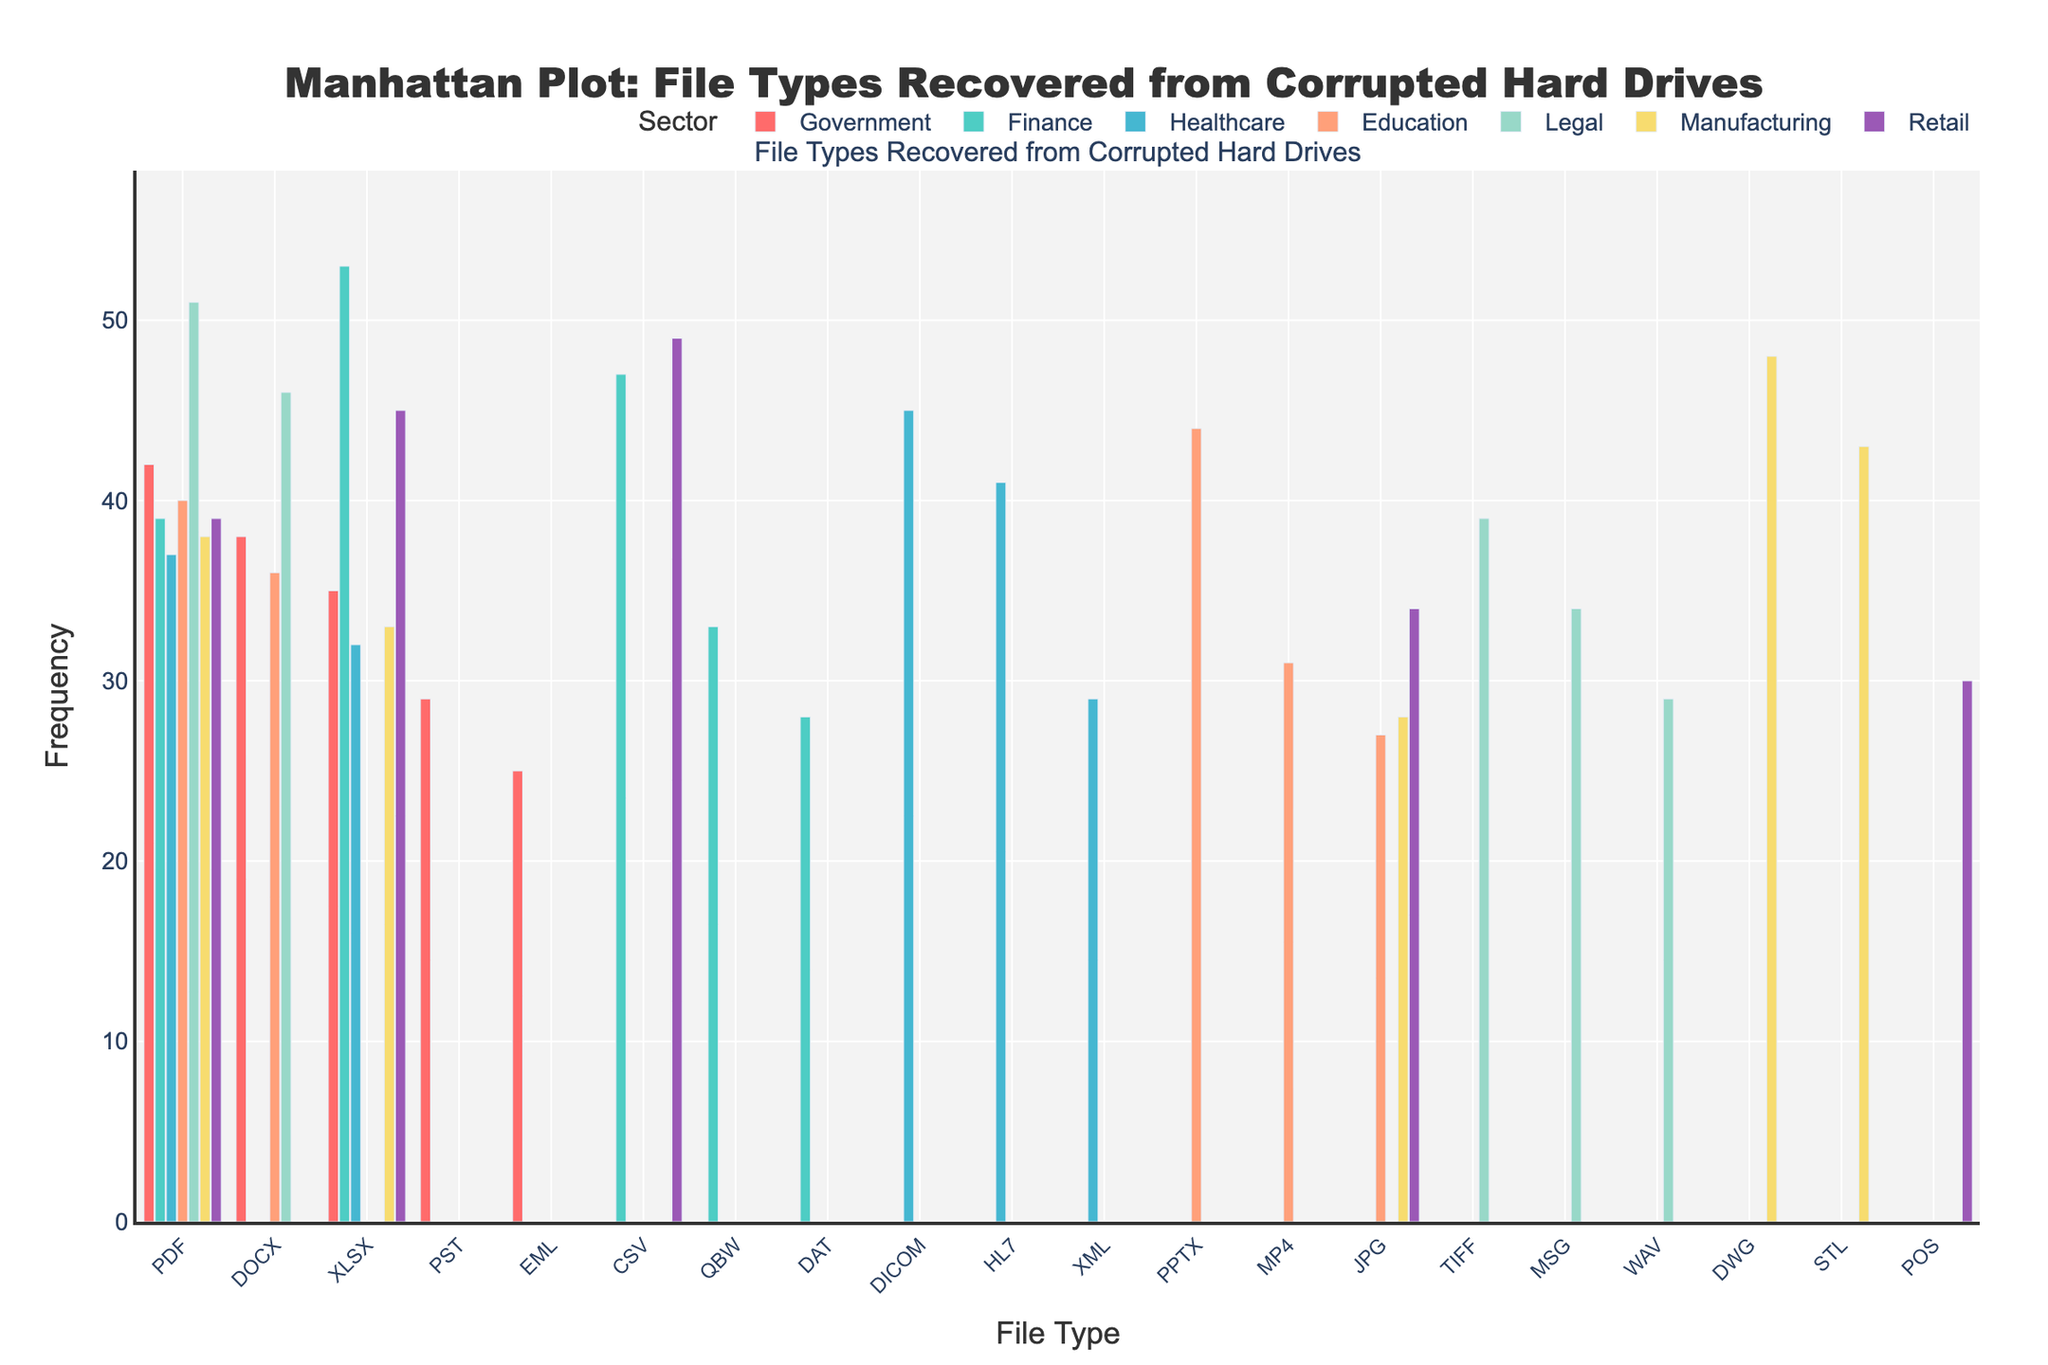Which sector has the highest frequency of a file type? By looking at the multiple bars for each sector and comparing their heights, the Manufacturing sector has the highest frequency for the DWG file type at 48.
Answer: Manufacturing What is the most common file type recovered across all sectors? By scanning the chart and noting the highest frequency bar for each file type across the sectors, the XLSX file type is most frequently recovered at 53 occurrences in the Finance sector.
Answer: XLSX Which file type is most frequent in the Government sector? Within the Government sector bars, the PDF file type has the highest frequency at 42.
Answer: PDF How many different file types are charted in the Healthcare sector? Look at the Healthcare sector bars, which represent five different file types: DICOM, HL7, PDF, XLSX, and XML.
Answer: 5 What is the total frequency for PDF file types across all sectors? Add the frequencies of PDF files in all sectors: Government (42), Finance (39), Healthcare (37), Education (40), Legal (51), Manufacturing (38), and Retail (39). The total is 42 + 39 + 37 + 40 + 51 + 38 + 39 = 286.
Answer: 286 Which file type has the lowest frequency in the Retail sector? Compare the frequencies of file types in the Retail sector and the POS file type has the lowest frequency at 30.
Answer: POS Are there any sectors where DOCX files have higher frequency than PDF files? DOCX and PDF bars for each sector: In the Government sector, PDF (42) is higher than DOCX (38); in the Education sector, PDF (40) is higher than DOCX (36); in the Legal sector, DOCX (46) is lower than PDF (51). There are no sectors where DOCX is higher than PDF.
Answer: No Which sector has the highest number of file types represented? Count the number of bars for each sector. Each sector has 5 different file types represented in the plot.
Answer: All sectors are equal What is the difference in frequency between the most common file type in the Finance sector and the least common in the Healthcare sector? The most common file type in Finance is XLSX (53), and the least common in Healthcare is XML (29). The difference is 53 - 29 = 24.
Answer: 24 